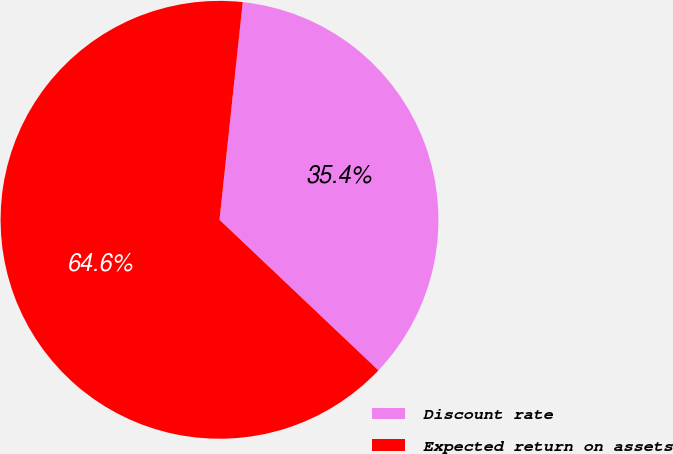Convert chart. <chart><loc_0><loc_0><loc_500><loc_500><pie_chart><fcel>Discount rate<fcel>Expected return on assets<nl><fcel>35.38%<fcel>64.62%<nl></chart> 